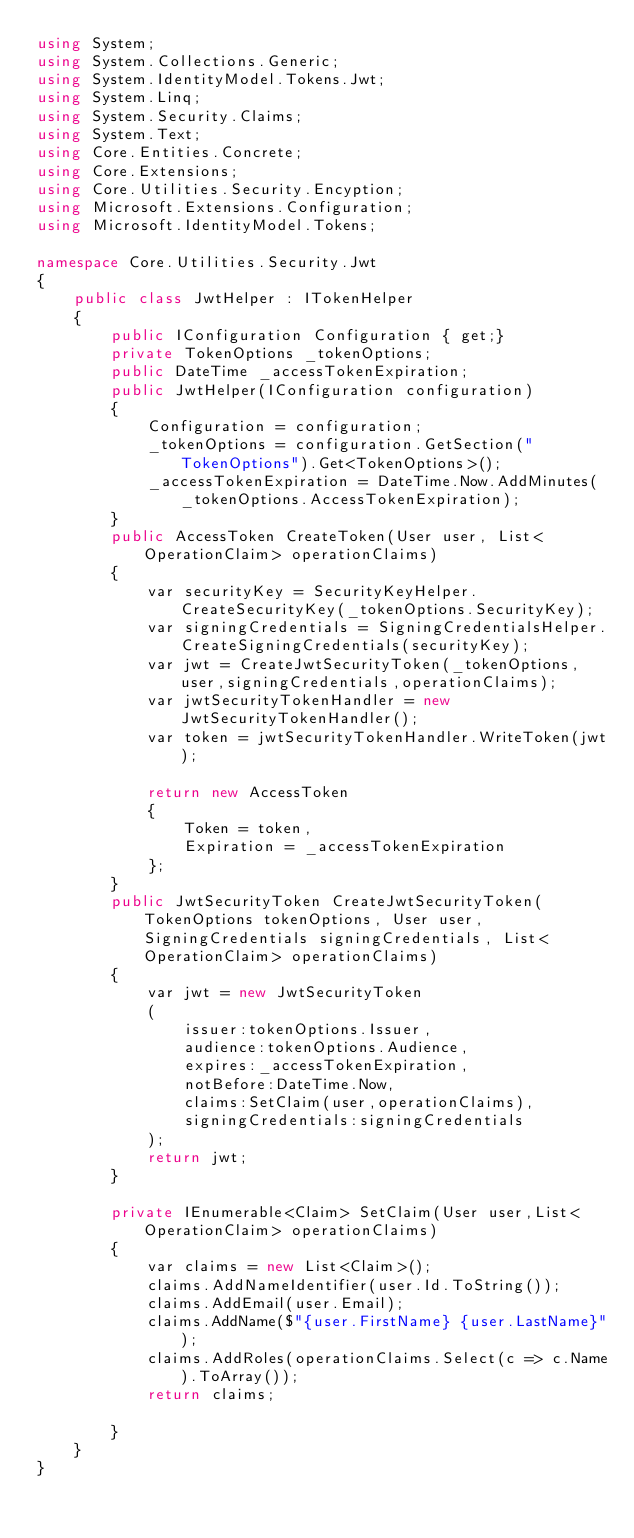<code> <loc_0><loc_0><loc_500><loc_500><_C#_>using System;
using System.Collections.Generic;
using System.IdentityModel.Tokens.Jwt;
using System.Linq;
using System.Security.Claims;
using System.Text;
using Core.Entities.Concrete;
using Core.Extensions;
using Core.Utilities.Security.Encyption;
using Microsoft.Extensions.Configuration;
using Microsoft.IdentityModel.Tokens;

namespace Core.Utilities.Security.Jwt
{
    public class JwtHelper : ITokenHelper
    {
        public IConfiguration Configuration { get;}
        private TokenOptions _tokenOptions;
        public DateTime _accessTokenExpiration;
        public JwtHelper(IConfiguration configuration)
        {
            Configuration = configuration;
            _tokenOptions = configuration.GetSection("TokenOptions").Get<TokenOptions>();
            _accessTokenExpiration = DateTime.Now.AddMinutes(_tokenOptions.AccessTokenExpiration);
        }
        public AccessToken CreateToken(User user, List<OperationClaim> operationClaims)
        {
            var securityKey = SecurityKeyHelper.CreateSecurityKey(_tokenOptions.SecurityKey);
            var signingCredentials = SigningCredentialsHelper.CreateSigningCredentials(securityKey);
            var jwt = CreateJwtSecurityToken(_tokenOptions,user,signingCredentials,operationClaims);
            var jwtSecurityTokenHandler = new JwtSecurityTokenHandler();
            var token = jwtSecurityTokenHandler.WriteToken(jwt);

            return new AccessToken
            {
                Token = token,
                Expiration = _accessTokenExpiration
            };
        }
        public JwtSecurityToken CreateJwtSecurityToken(TokenOptions tokenOptions, User user, SigningCredentials signingCredentials, List<OperationClaim> operationClaims)
        {
            var jwt = new JwtSecurityToken
            (
                issuer:tokenOptions.Issuer,
                audience:tokenOptions.Audience,
                expires:_accessTokenExpiration,
                notBefore:DateTime.Now,
                claims:SetClaim(user,operationClaims),
                signingCredentials:signingCredentials
            );
            return jwt;
        }

        private IEnumerable<Claim> SetClaim(User user,List<OperationClaim> operationClaims)
        {
            var claims = new List<Claim>();
            claims.AddNameIdentifier(user.Id.ToString());
            claims.AddEmail(user.Email);
            claims.AddName($"{user.FirstName} {user.LastName}");
            claims.AddRoles(operationClaims.Select(c => c.Name).ToArray());
            return claims;
            
        }
    }
}</code> 